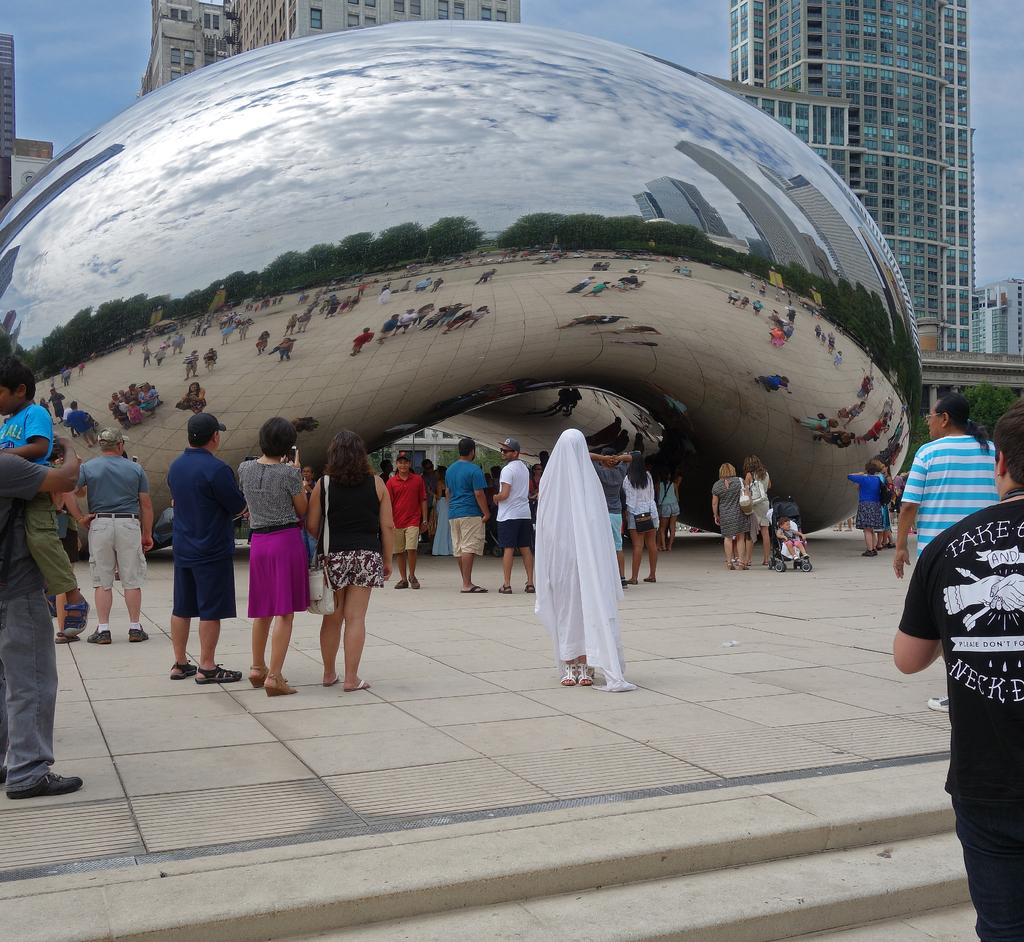How many people are in the image? There is a group of people in the image. What object is visible in the image that can hold a liquid? There is a glass in the image. What does the glass reflect in the image? The glass reflects a scene with people, buildings, trees, and sky with clouds. What type of structures can be seen in the background of the image? The background of the image includes buildings. What part of the natural environment is visible in the background of the image? The sky is visible in the background of the image. What type of shoe can be seen on the secretary in the image? There is no secretary or shoe present in the image. 